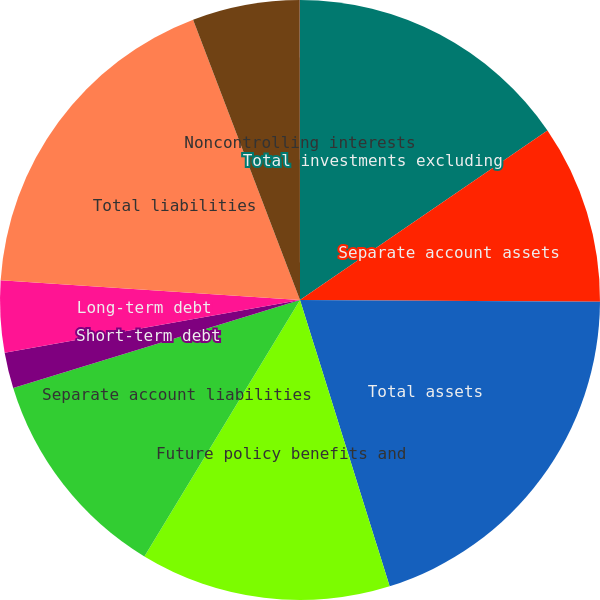<chart> <loc_0><loc_0><loc_500><loc_500><pie_chart><fcel>Total investments excluding<fcel>Separate account assets<fcel>Total assets<fcel>Future policy benefits and<fcel>Separate account liabilities<fcel>Short-term debt<fcel>Long-term debt<fcel>Total liabilities<fcel>Prudential Financial Inc<fcel>Noncontrolling interests<nl><fcel>15.44%<fcel>9.65%<fcel>20.08%<fcel>13.51%<fcel>11.58%<fcel>1.93%<fcel>3.86%<fcel>18.15%<fcel>5.79%<fcel>0.01%<nl></chart> 